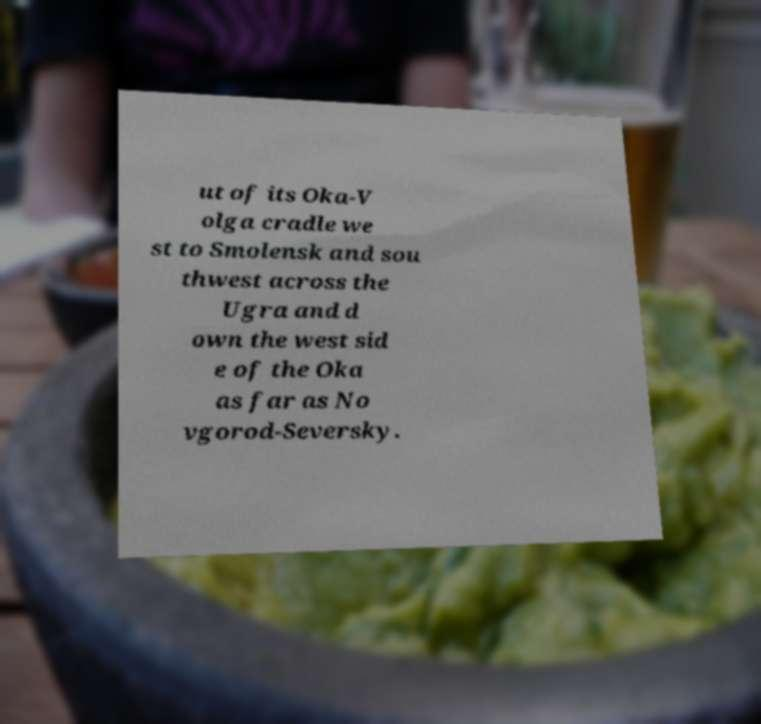Please read and relay the text visible in this image. What does it say? ut of its Oka-V olga cradle we st to Smolensk and sou thwest across the Ugra and d own the west sid e of the Oka as far as No vgorod-Seversky. 